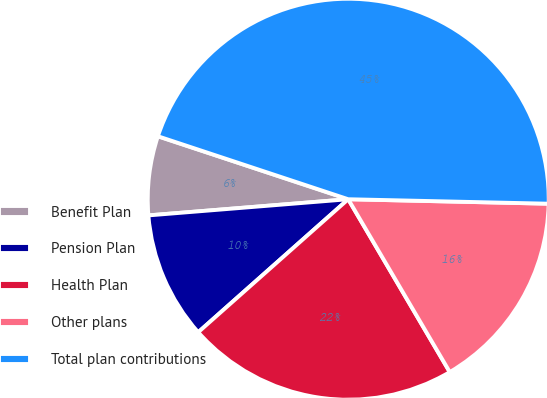Convert chart. <chart><loc_0><loc_0><loc_500><loc_500><pie_chart><fcel>Benefit Plan<fcel>Pension Plan<fcel>Health Plan<fcel>Other plans<fcel>Total plan contributions<nl><fcel>6.37%<fcel>10.26%<fcel>21.91%<fcel>16.19%<fcel>45.27%<nl></chart> 